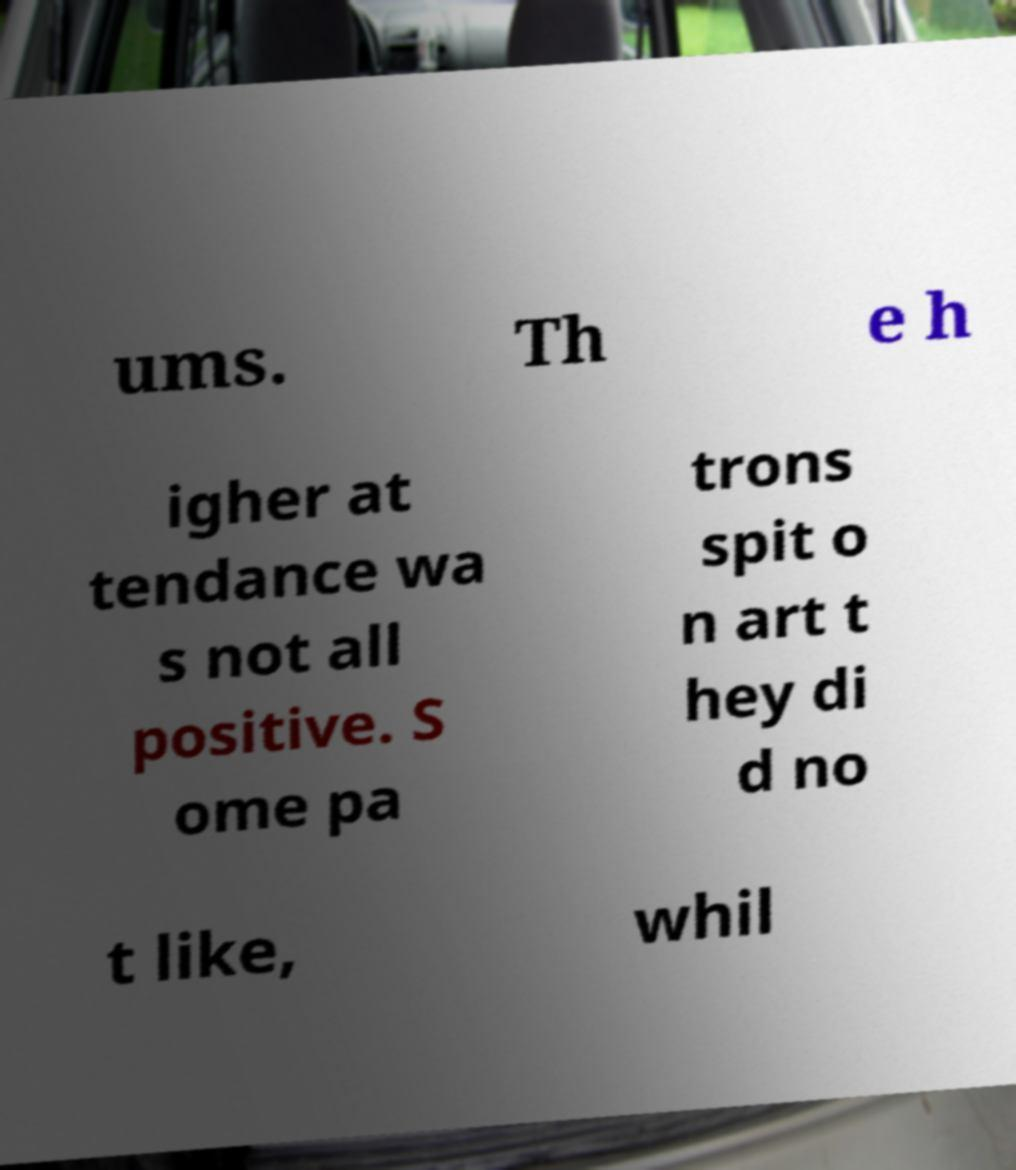Could you extract and type out the text from this image? ums. Th e h igher at tendance wa s not all positive. S ome pa trons spit o n art t hey di d no t like, whil 